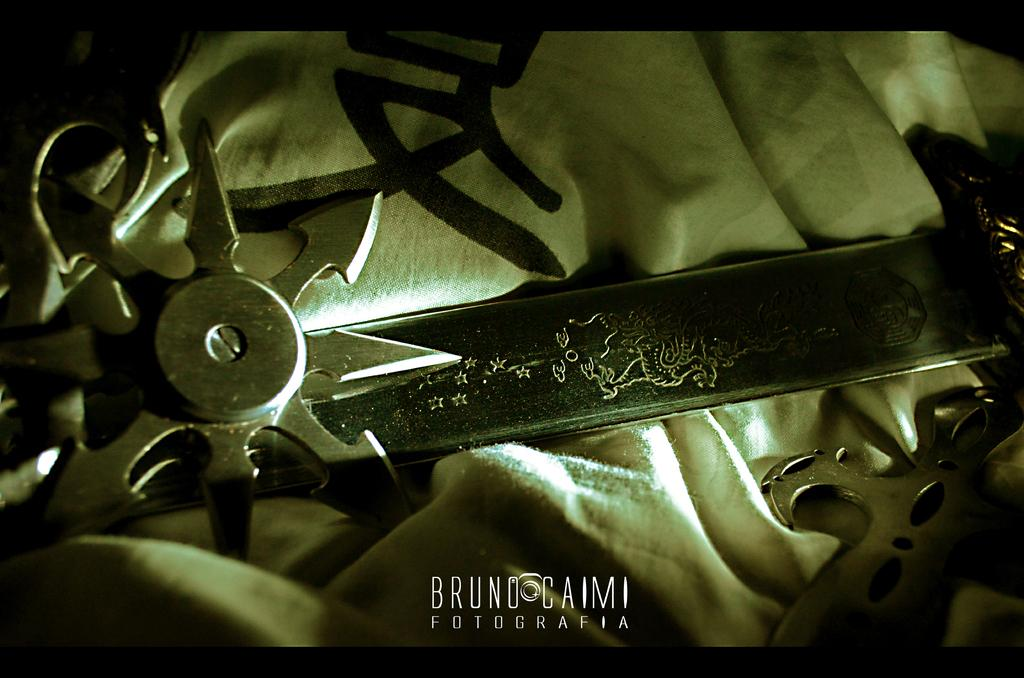What objects are placed on the cloth in the image? There are knives on the cloth in the image. Is there any text present in the image? Yes, there is some text written at the bottom of the image. What type of voice can be heard coming from the knives in the image? There is no voice coming from the knives in the image, as they are inanimate objects. 